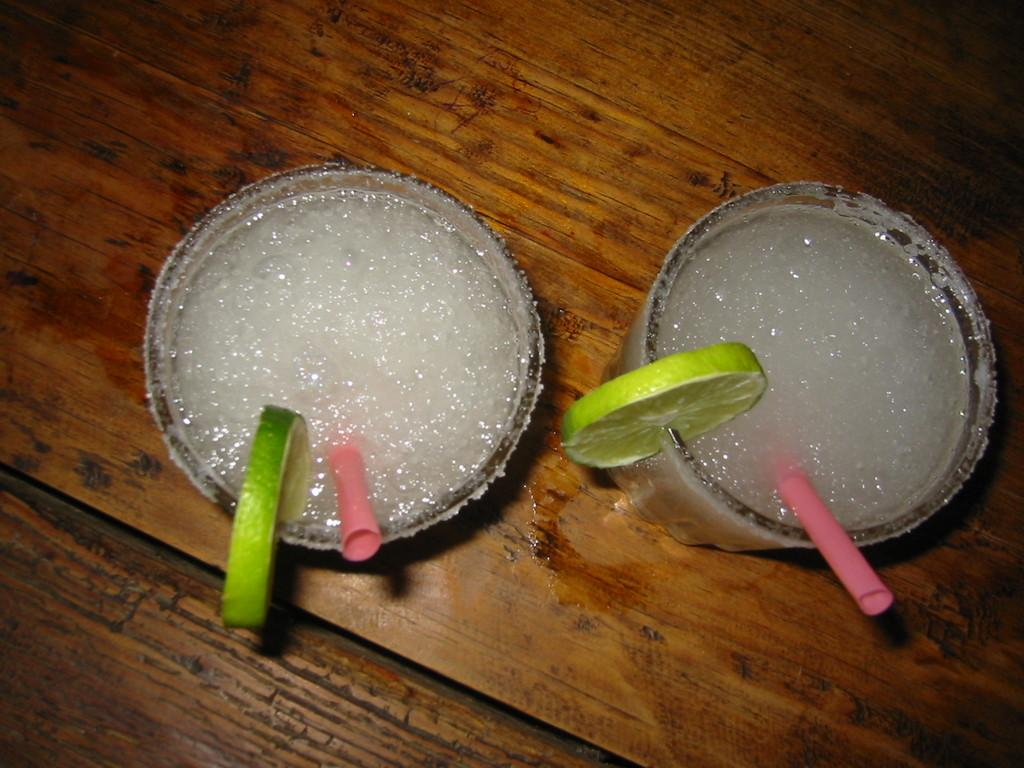What is in the glasses that are visible in the image? There are glasses with a drink in the image. What can be seen inside the glasses? There is a lemon slice in the glass, and a straw is also present. What is the surface on which the glasses are placed? The glasses are on a wooden surface. What type of plants are growing on the glasses in the image? There are no plants growing on the glasses in the image. 